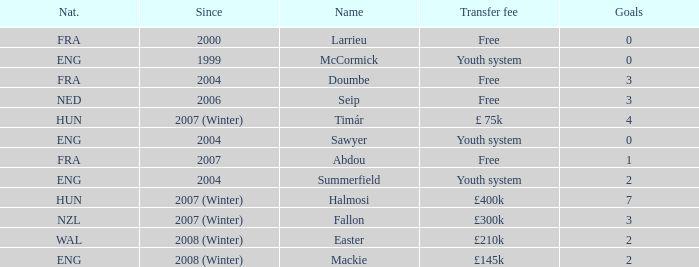From what year has the player with a £75k transfer fee been active? 2007 (Winter). 